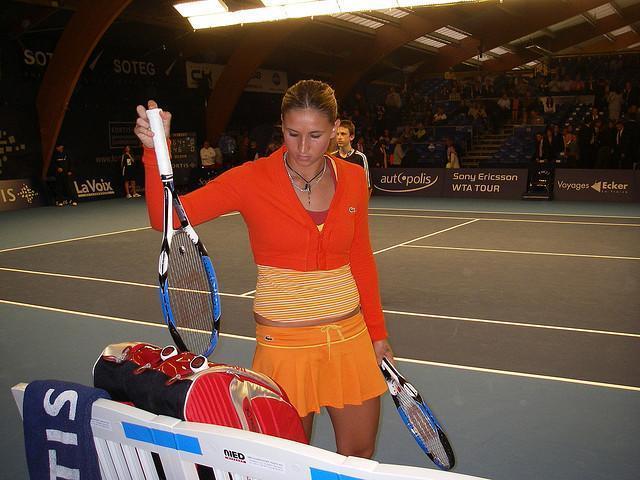How many rackets is she holding?
Give a very brief answer. 2. How many tennis rackets are in the picture?
Give a very brief answer. 2. How many people are there?
Give a very brief answer. 2. 